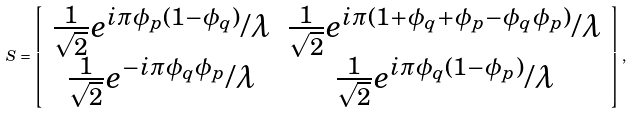<formula> <loc_0><loc_0><loc_500><loc_500>S = \left [ \begin{array} [ c ] { c c } \frac { 1 } { \sqrt { 2 } } e ^ { i \pi \phi _ { p } ( 1 - \phi _ { q } ) } / \lambda & \frac { 1 } { \sqrt { 2 } } e ^ { i \pi ( 1 + \phi _ { q } + \phi _ { p } - \phi _ { q } \phi _ { p } ) } / \lambda \\ \frac { 1 } { \sqrt { 2 } } e ^ { - i \pi \phi _ { q } \phi _ { p } } / \lambda & \frac { 1 } { \sqrt { 2 } } e ^ { i \pi \phi _ { q } ( 1 - \phi _ { p } ) } / \lambda \end{array} \right ] ,</formula> 